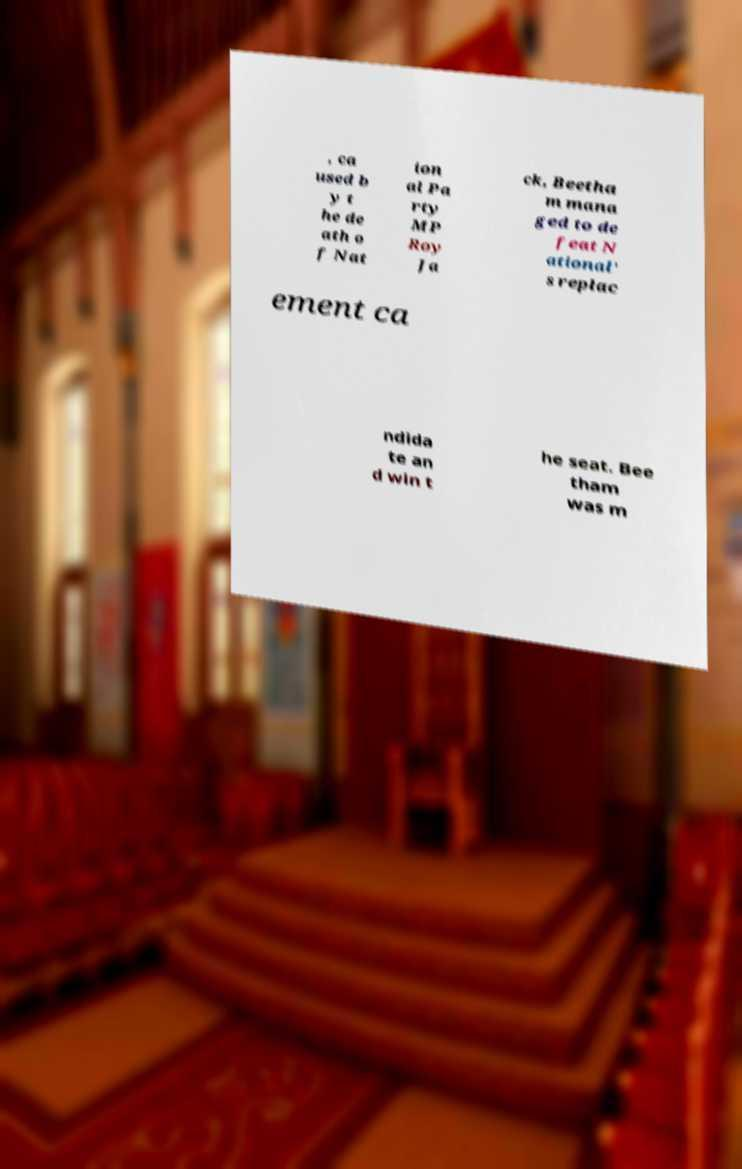There's text embedded in this image that I need extracted. Can you transcribe it verbatim? , ca used b y t he de ath o f Nat ion al Pa rty MP Roy Ja ck, Beetha m mana ged to de feat N ational' s replac ement ca ndida te an d win t he seat. Bee tham was m 